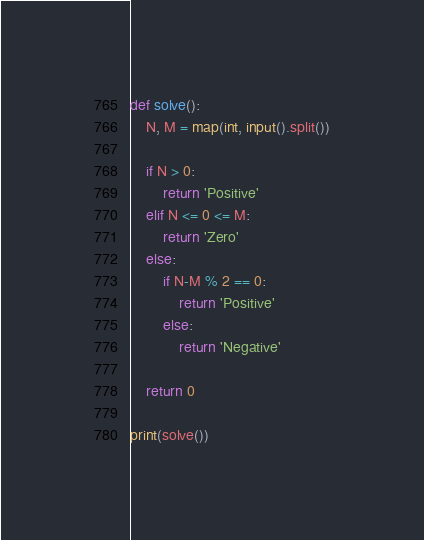Convert code to text. <code><loc_0><loc_0><loc_500><loc_500><_Python_>def solve():
    N, M = map(int, input().split())
    
    if N > 0:
        return 'Positive'
    elif N <= 0 <= M:
        return 'Zero'
    else:
        if N-M % 2 == 0:
            return 'Positive'
        else:
            return 'Negative'
            
    return 0

print(solve())</code> 